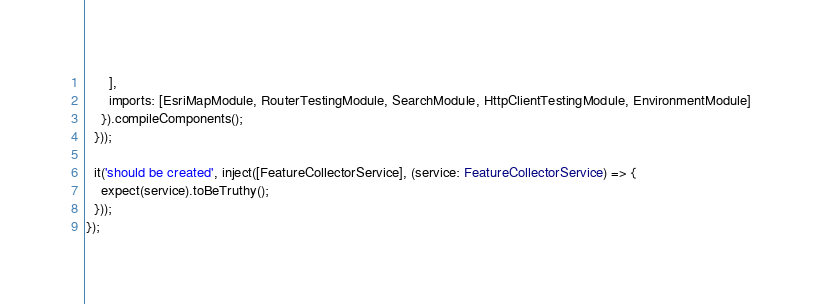Convert code to text. <code><loc_0><loc_0><loc_500><loc_500><_TypeScript_>      ],
      imports: [EsriMapModule, RouterTestingModule, SearchModule, HttpClientTestingModule, EnvironmentModule]
    }).compileComponents();
  }));

  it('should be created', inject([FeatureCollectorService], (service: FeatureCollectorService) => {
    expect(service).toBeTruthy();
  }));
});
</code> 